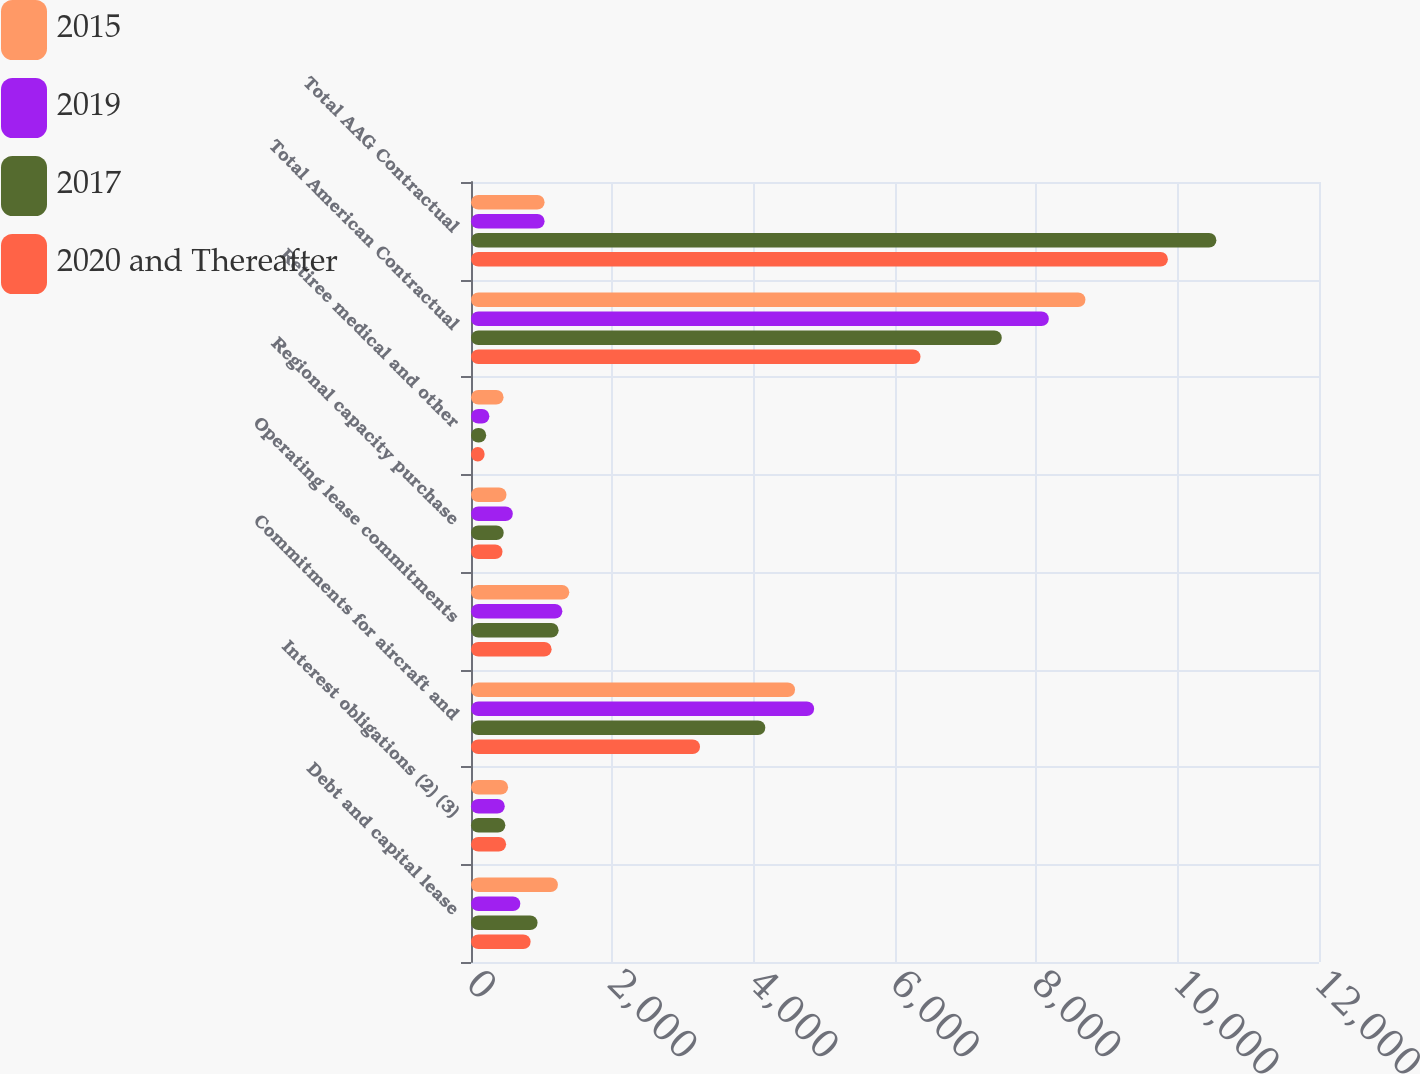<chart> <loc_0><loc_0><loc_500><loc_500><stacked_bar_chart><ecel><fcel>Debt and capital lease<fcel>Interest obligations (2) (3)<fcel>Commitments for aircraft and<fcel>Operating lease commitments<fcel>Regional capacity purchase<fcel>Retiree medical and other<fcel>Total American Contractual<fcel>Total AAG Contractual<nl><fcel>2015<fcel>1230<fcel>525<fcel>4586<fcel>1391<fcel>502<fcel>461<fcel>8695<fcel>1041.5<nl><fcel>2019<fcel>698<fcel>478<fcel>4856<fcel>1293<fcel>592<fcel>260<fcel>8177<fcel>1041.5<nl><fcel>2017<fcel>942<fcel>486<fcel>4165<fcel>1240<fcel>463<fcel>215<fcel>7511<fcel>10548<nl><fcel>2020 and Thereafter<fcel>844<fcel>497<fcel>3241<fcel>1141<fcel>446<fcel>192<fcel>6361<fcel>9862<nl></chart> 